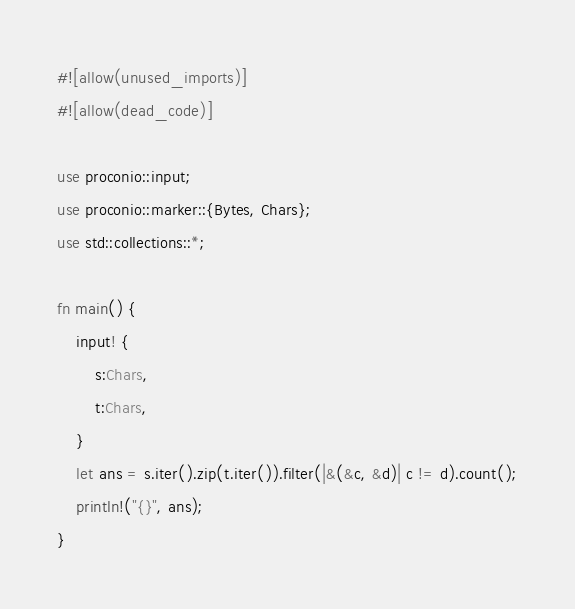Convert code to text. <code><loc_0><loc_0><loc_500><loc_500><_Rust_>#![allow(unused_imports)]
#![allow(dead_code)]

use proconio::input;
use proconio::marker::{Bytes, Chars};
use std::collections::*;

fn main() {
    input! {
        s:Chars,
        t:Chars,
    }
    let ans = s.iter().zip(t.iter()).filter(|&(&c, &d)| c != d).count();
    println!("{}", ans);
}</code> 